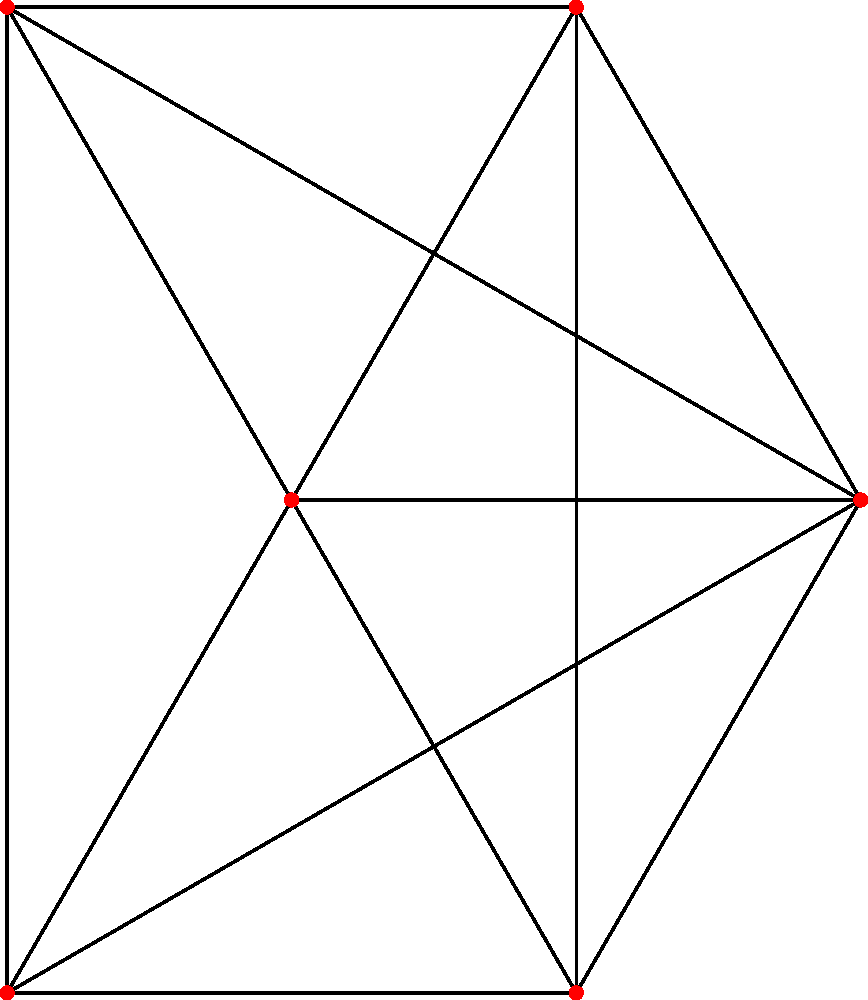Рассмотрите планарный граф, показанный выше. Какое минимальное количество цветов требуется для раскраски вершин этого графа так, чтобы никакие две смежные вершины не имели одинакового цвета? Для решения этой задачи воспользуемся следующими шагами:

1) Сначала отметим, что данный граф является полным графом на 6 вершинах, обозначаемым как $K_6$.

2) Для полных графов существует простое правило: минимальное число цветов, необходимое для раскраски вершин, равно числу вершин графа. Это связано с тем, что каждая вершина соединена со всеми остальными, и поэтому все вершины должны иметь разные цвета.

3) Однако, в вопросе указано, что граф является планарным. Это важное уточнение, так как $K_6$ на самом деле не является планарным графом.

4) Согласно теореме о четырех красках, любой планарный граф можно раскрасить, используя не более четырех цветов.

5) Таким образом, мы приходим к противоречию: граф не может быть одновременно полным на 6 вершинах и планарным.

6) Это означает, что в изображении графа должны отсутствовать некоторые ребра, чтобы он стал планарным.

7) В худшем случае, когда граф остается максимально связным, но при этом планарным, для его раскраски потребуется 4 цвета (согласно теореме о четырех красках).

Таким образом, минимальное количество цветов, необходимое для раскраски вершин данного планарного графа, равно 4.
Answer: 4 цвета 